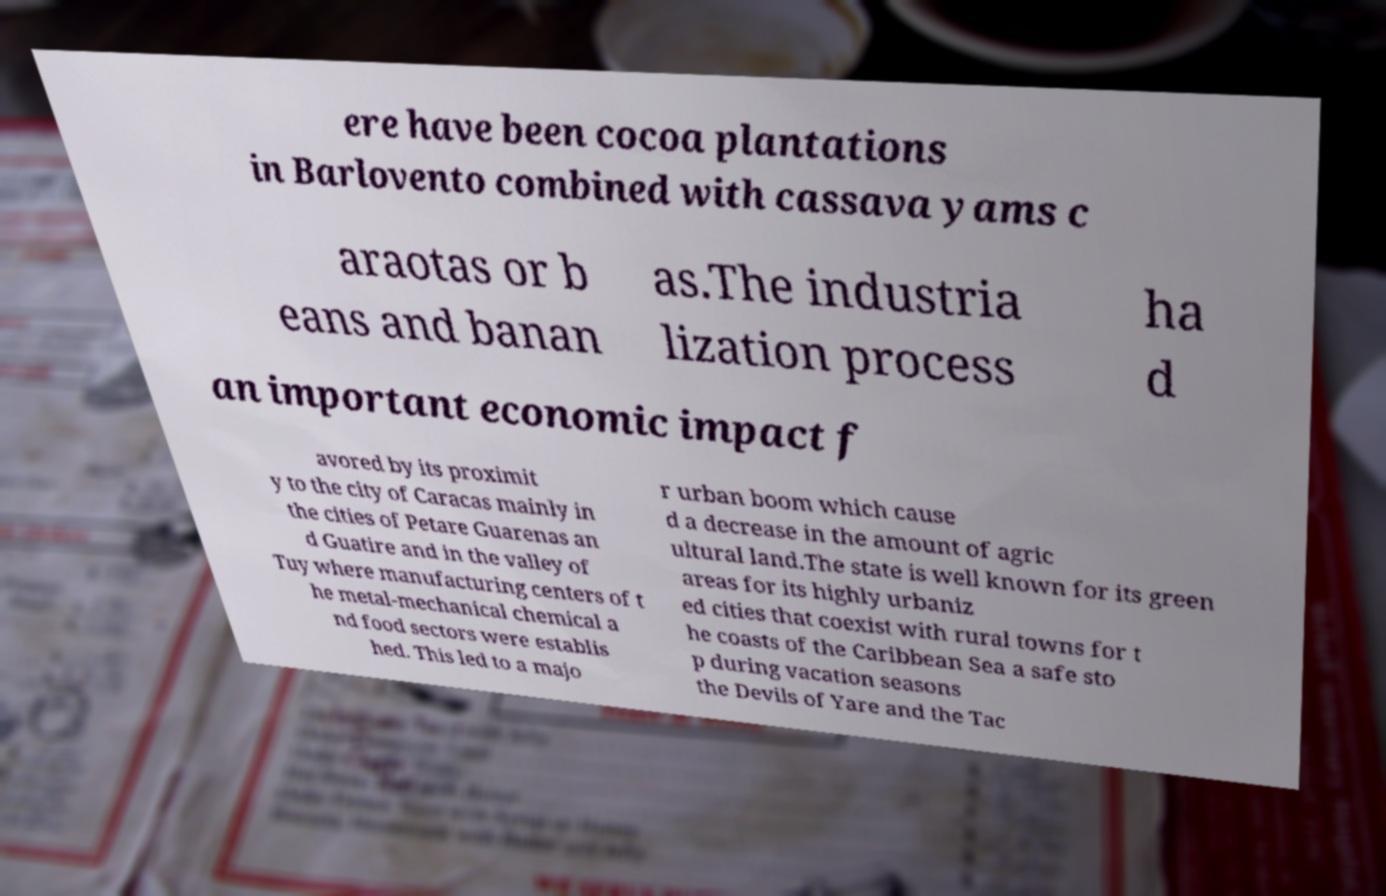Can you read and provide the text displayed in the image?This photo seems to have some interesting text. Can you extract and type it out for me? ere have been cocoa plantations in Barlovento combined with cassava yams c araotas or b eans and banan as.The industria lization process ha d an important economic impact f avored by its proximit y to the city of Caracas mainly in the cities of Petare Guarenas an d Guatire and in the valley of Tuy where manufacturing centers of t he metal-mechanical chemical a nd food sectors were establis hed. This led to a majo r urban boom which cause d a decrease in the amount of agric ultural land.The state is well known for its green areas for its highly urbaniz ed cities that coexist with rural towns for t he coasts of the Caribbean Sea a safe sto p during vacation seasons the Devils of Yare and the Tac 